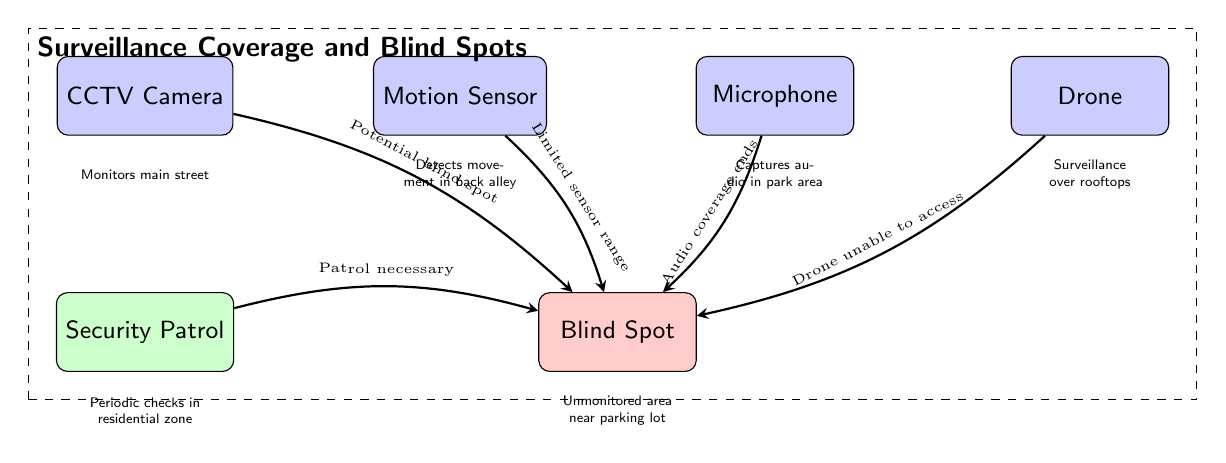What type of surveillance equipment is located at (0,0)? The diagram shows a node labeled "CCTV Camera" at the coordinates (0,0). Therefore, the equipment located there is a CCTV Camera.
Answer: CCTV Camera How many pieces of equipment are depicted in the diagram? By counting the elements in the diagram, there are four pieces of surveillance equipment: CCTV Camera, Motion Sensor, Microphone, and Drone. Thus, the total is four.
Answer: 4 What is the relationship between the Motion Sensor and the Blind Spot? The diagram indicates an edge from the Motion Sensor to the Blind Spot, labeled "Limited sensor range." This implies that the Motion Sensor has a restricted area it can cover, leading to a blind spot.
Answer: Limited sensor range Which area requires periodic checks according to the diagram? The diagram notes that the "Security Patrol" provides periodic checks in the residential zone, which is identified at the location of the patrol node.
Answer: Residential zone What does the Microphone cover in the area? The Microphone is positioned in the diagram to "Capture audio in park area," indicating the specific function and area of coverage for this piece of equipment.
Answer: Capture audio in park area Why is a security patrol necessary according to the diagram? The diagram illustrates an edge from the Security Patrol to the Blind Spot with the label "Patrol necessary," suggesting that the blind spot is unmonitored and requires regular security checks by a patrol.
Answer: Patrol necessary What kinds of areas are indicated as blind spots in the diagram? The diagram shows a single blind spot that is unmonitored near a parking lot, as labeled in the diagram.
Answer: Unmonitored area near parking lot Which surveillance equipment provides coverage over rooftops? According to the diagram, the "Drone" is responsible for surveillance over rooftops, denoted with text aligned below this equipment node.
Answer: Drone What expression denotes the unmonitored area in relation to CCTV coverage? The edge from the CCTV Camera to the Blind Spot is labeled "Potential blind spot," suggesting that the area covered by the CCTV has gaps leading to unmonitored regions.
Answer: Potential blind spot 